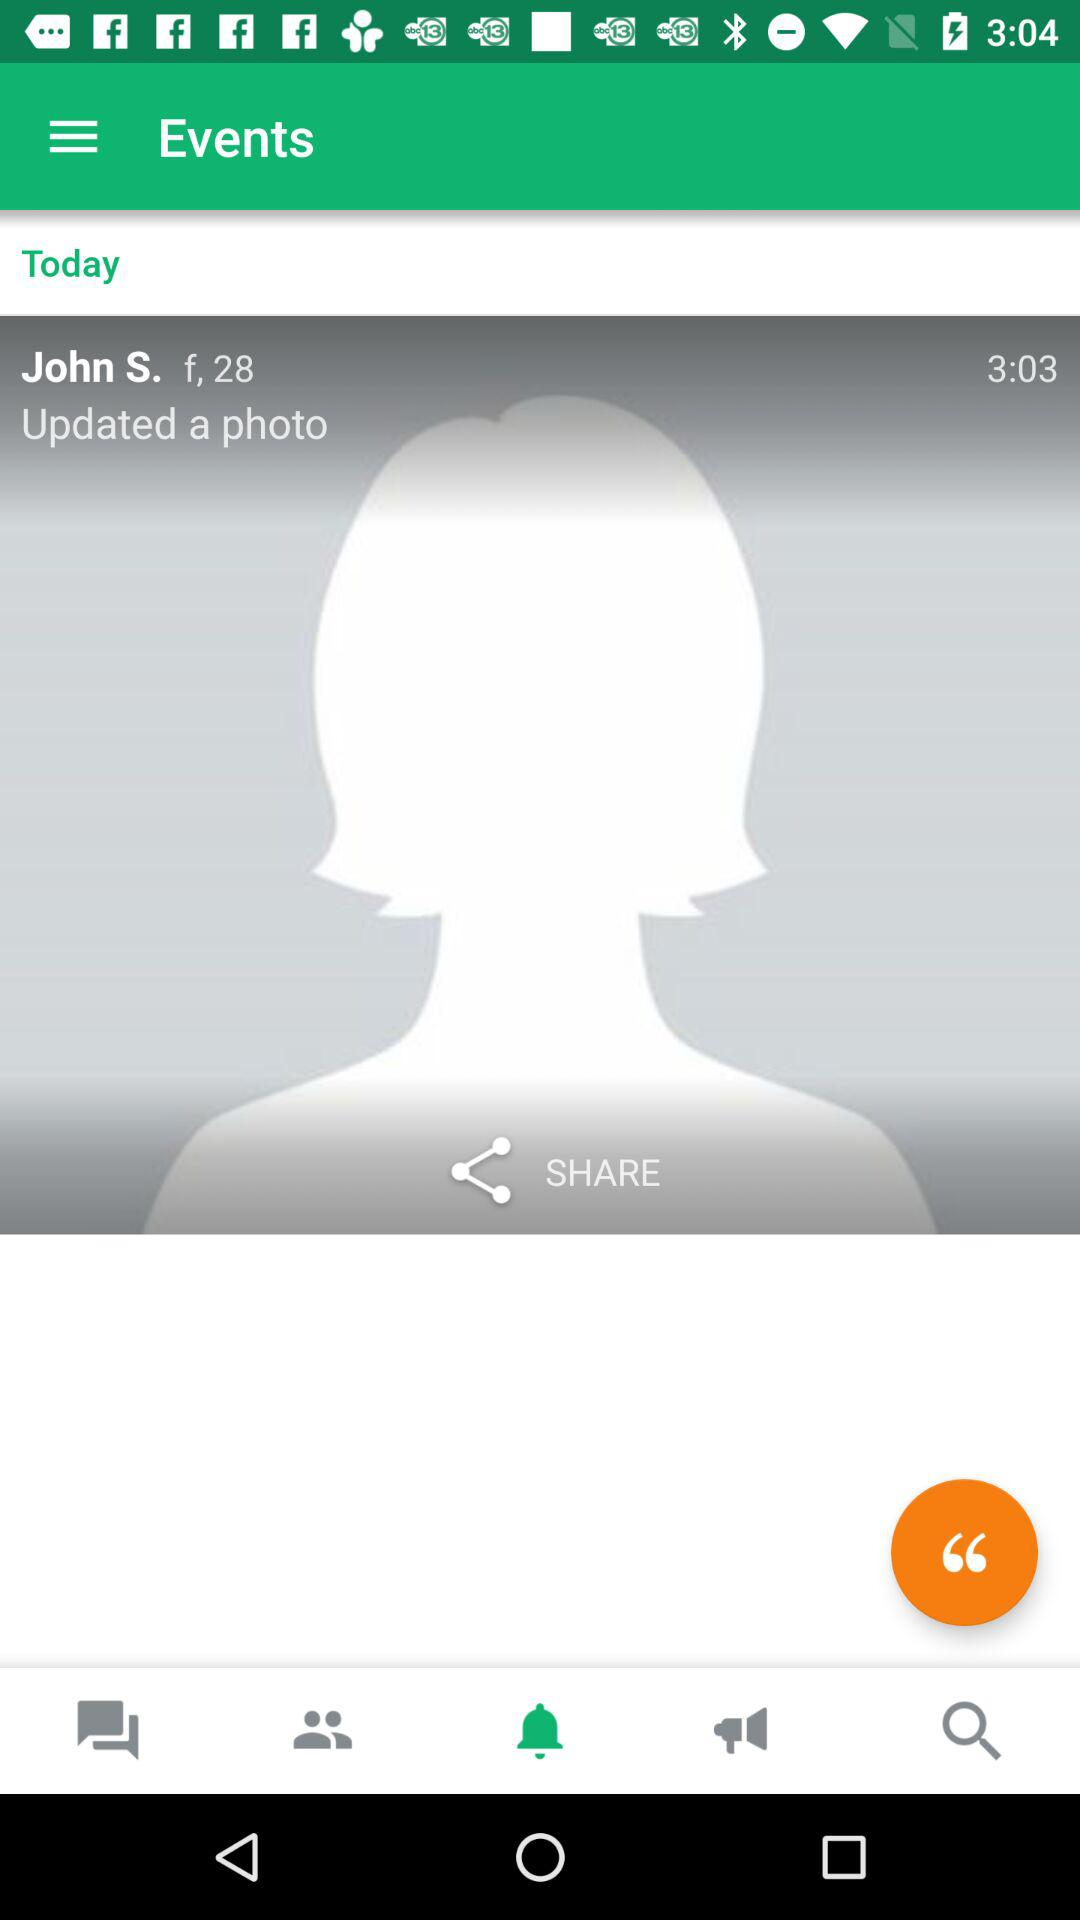How many messages are there?
When the provided information is insufficient, respond with <no answer>. <no answer> 